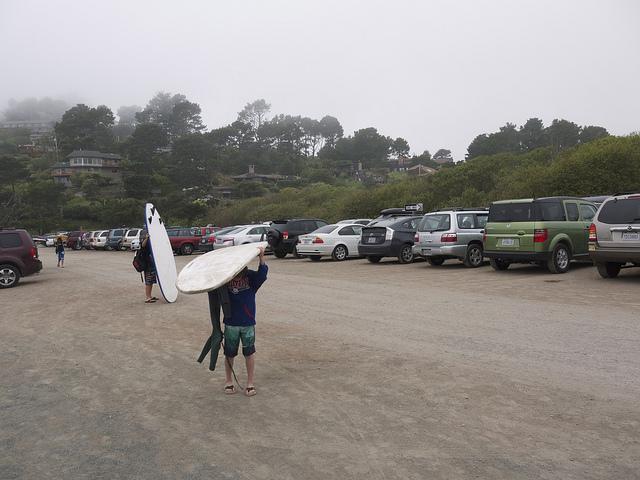Where are persons carrying the white items going?
Pick the right solution, then justify: 'Answer: answer
Rationale: rationale.'
Options: Pool hall, swimming pool, ocean, bar. Answer: ocean.
Rationale: This is the most obvious answer given that those are surfboards. 